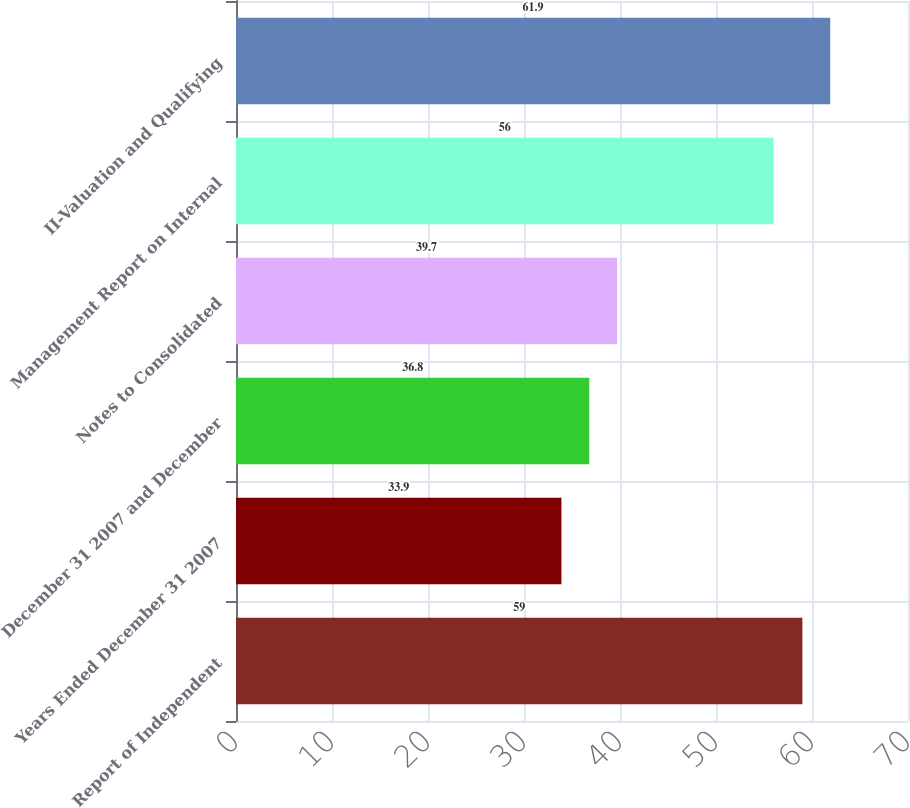Convert chart to OTSL. <chart><loc_0><loc_0><loc_500><loc_500><bar_chart><fcel>Report of Independent<fcel>Years Ended December 31 2007<fcel>December 31 2007 and December<fcel>Notes to Consolidated<fcel>Management Report on Internal<fcel>II-Valuation and Qualifying<nl><fcel>59<fcel>33.9<fcel>36.8<fcel>39.7<fcel>56<fcel>61.9<nl></chart> 